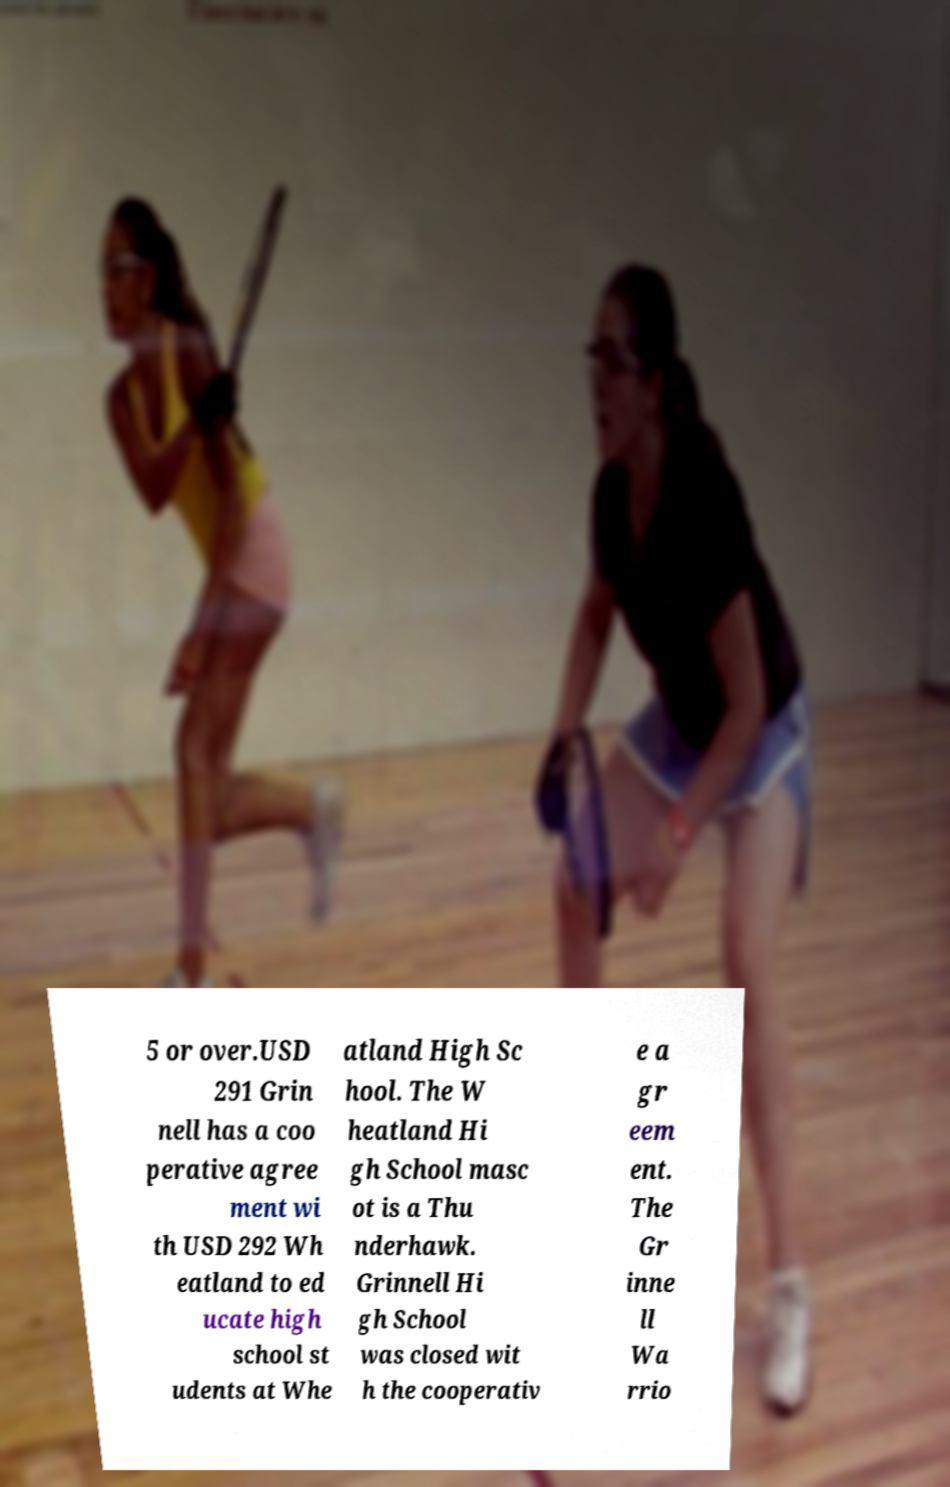Can you accurately transcribe the text from the provided image for me? 5 or over.USD 291 Grin nell has a coo perative agree ment wi th USD 292 Wh eatland to ed ucate high school st udents at Whe atland High Sc hool. The W heatland Hi gh School masc ot is a Thu nderhawk. Grinnell Hi gh School was closed wit h the cooperativ e a gr eem ent. The Gr inne ll Wa rrio 